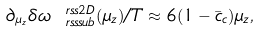Convert formula to latex. <formula><loc_0><loc_0><loc_500><loc_500>\partial _ { \mu _ { z } } \delta \omega ^ { \ r s s 2 D } _ { \ r s s s u b } ( \mu _ { z } ) / T \approx 6 ( 1 - \bar { c } _ { c } ) \mu _ { z } ,</formula> 